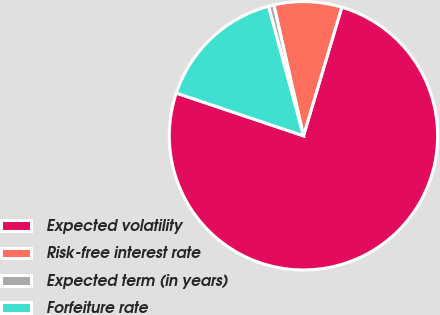Convert chart. <chart><loc_0><loc_0><loc_500><loc_500><pie_chart><fcel>Expected volatility<fcel>Risk-free interest rate<fcel>Expected term (in years)<fcel>Forfeiture rate<nl><fcel>75.55%<fcel>8.15%<fcel>0.66%<fcel>15.64%<nl></chart> 